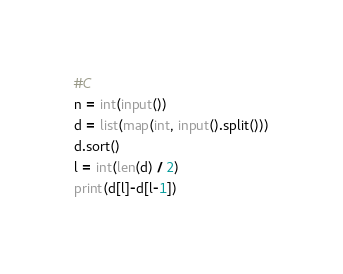Convert code to text. <code><loc_0><loc_0><loc_500><loc_500><_Python_>#C
n = int(input())
d = list(map(int, input().split()))
d.sort()
l = int(len(d) / 2)
print(d[l]-d[l-1])</code> 